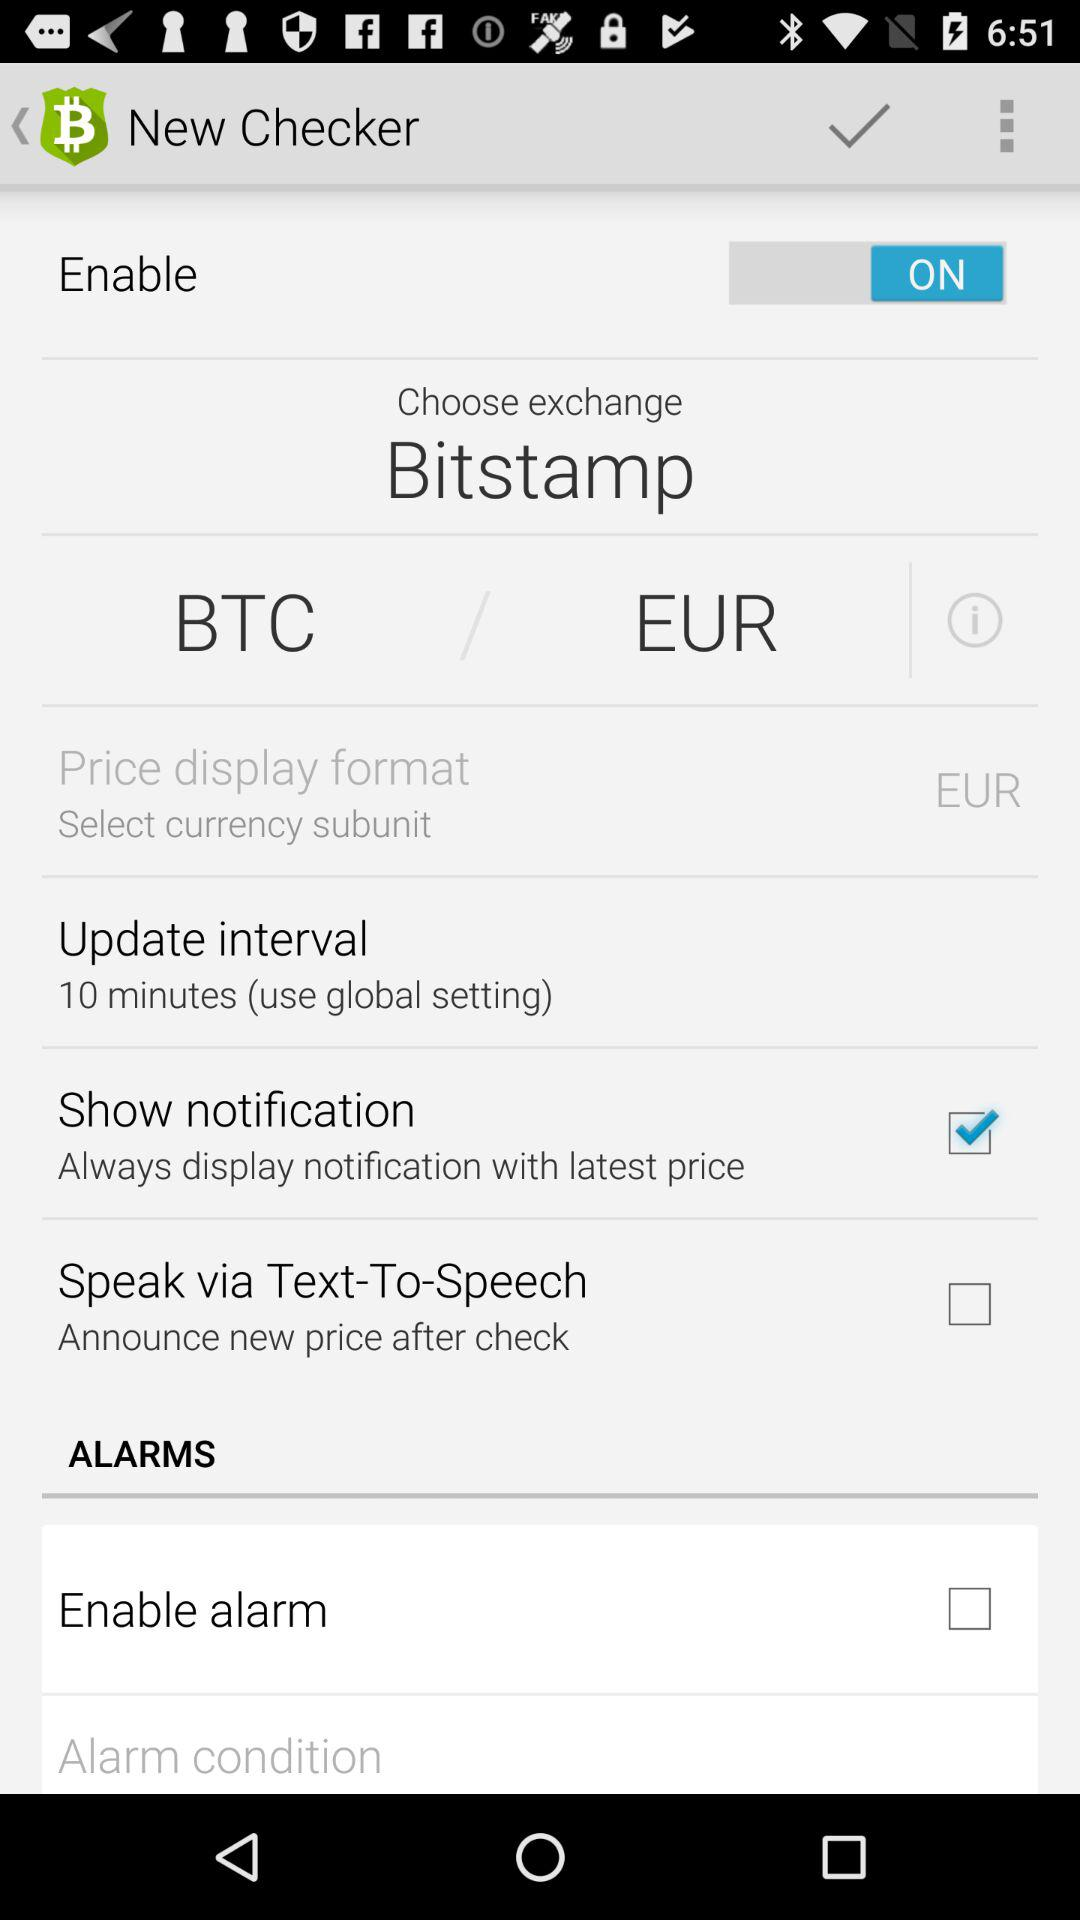What is the status of "Speak via Text-To-Speech"? The status of "Speak via Text-To-Speech" is "off". 